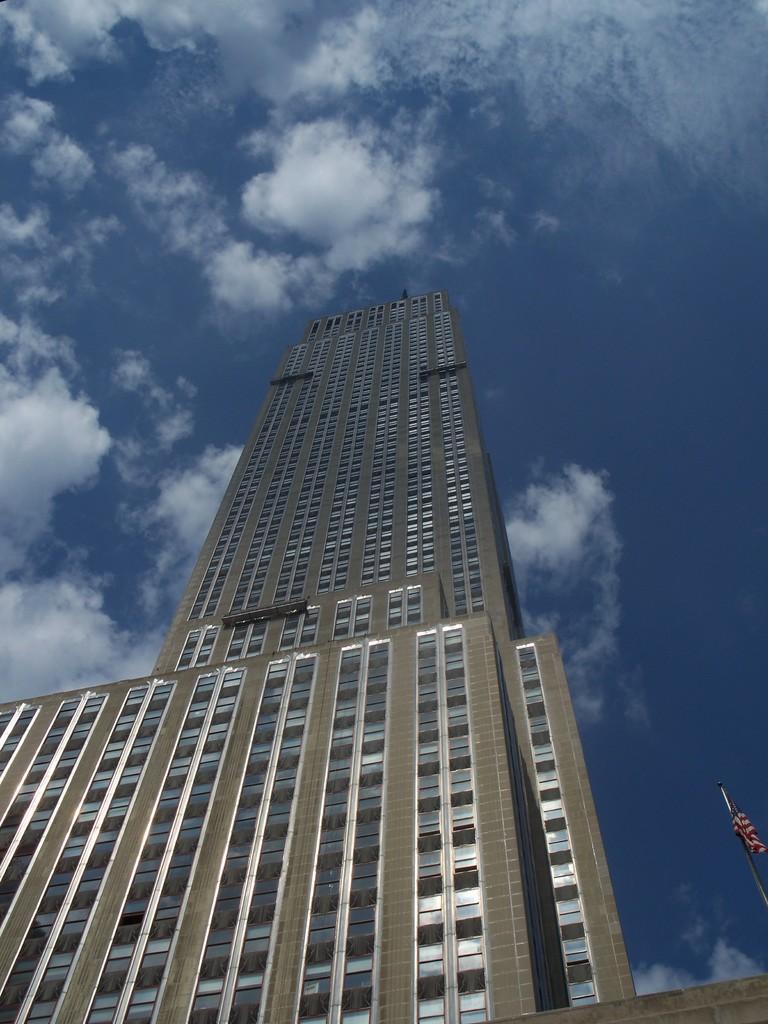Describe this image in one or two sentences. There is a building. On the right side there is a pole with a flag. In the background there is sky with clouds. 